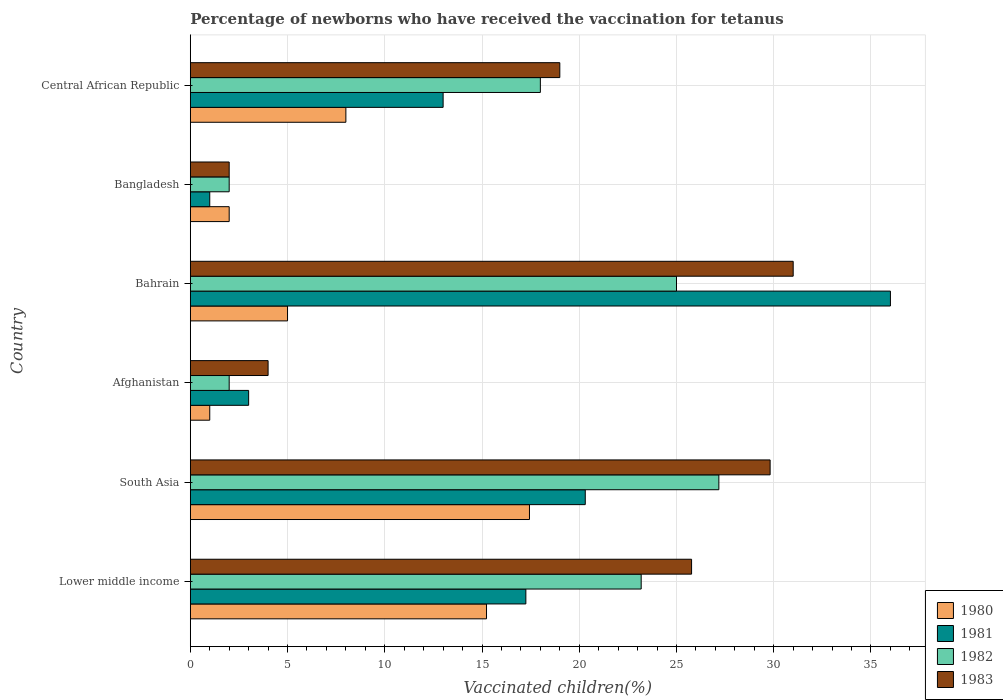How many different coloured bars are there?
Ensure brevity in your answer.  4. How many groups of bars are there?
Your response must be concise. 6. Are the number of bars per tick equal to the number of legend labels?
Make the answer very short. Yes. How many bars are there on the 2nd tick from the top?
Make the answer very short. 4. How many bars are there on the 1st tick from the bottom?
Your answer should be compact. 4. In how many cases, is the number of bars for a given country not equal to the number of legend labels?
Offer a terse response. 0. Across all countries, what is the maximum percentage of vaccinated children in 1982?
Your answer should be compact. 27.18. Across all countries, what is the minimum percentage of vaccinated children in 1980?
Your answer should be compact. 1. In which country was the percentage of vaccinated children in 1983 maximum?
Offer a very short reply. Bahrain. In which country was the percentage of vaccinated children in 1981 minimum?
Your answer should be very brief. Bangladesh. What is the total percentage of vaccinated children in 1980 in the graph?
Your answer should be compact. 48.67. What is the difference between the percentage of vaccinated children in 1980 in Bangladesh and that in South Asia?
Your answer should be very brief. -15.44. What is the difference between the percentage of vaccinated children in 1981 in South Asia and the percentage of vaccinated children in 1982 in Afghanistan?
Your response must be concise. 18.31. What is the average percentage of vaccinated children in 1980 per country?
Your response must be concise. 8.11. What is the difference between the percentage of vaccinated children in 1981 and percentage of vaccinated children in 1982 in South Asia?
Offer a terse response. -6.87. In how many countries, is the percentage of vaccinated children in 1982 greater than 15 %?
Ensure brevity in your answer.  4. What is the ratio of the percentage of vaccinated children in 1981 in Bangladesh to that in South Asia?
Your response must be concise. 0.05. Is the percentage of vaccinated children in 1982 in Bahrain less than that in Bangladesh?
Provide a succinct answer. No. Is the difference between the percentage of vaccinated children in 1981 in Central African Republic and South Asia greater than the difference between the percentage of vaccinated children in 1982 in Central African Republic and South Asia?
Offer a very short reply. Yes. What is the difference between the highest and the second highest percentage of vaccinated children in 1983?
Your answer should be compact. 1.19. What is the difference between the highest and the lowest percentage of vaccinated children in 1980?
Offer a very short reply. 16.44. Is the sum of the percentage of vaccinated children in 1982 in Bangladesh and South Asia greater than the maximum percentage of vaccinated children in 1981 across all countries?
Give a very brief answer. No. Is it the case that in every country, the sum of the percentage of vaccinated children in 1982 and percentage of vaccinated children in 1980 is greater than the sum of percentage of vaccinated children in 1981 and percentage of vaccinated children in 1983?
Your response must be concise. No. Is it the case that in every country, the sum of the percentage of vaccinated children in 1982 and percentage of vaccinated children in 1980 is greater than the percentage of vaccinated children in 1981?
Provide a short and direct response. No. How many countries are there in the graph?
Your answer should be very brief. 6. Does the graph contain any zero values?
Make the answer very short. No. How many legend labels are there?
Offer a very short reply. 4. What is the title of the graph?
Provide a succinct answer. Percentage of newborns who have received the vaccination for tetanus. Does "2003" appear as one of the legend labels in the graph?
Give a very brief answer. No. What is the label or title of the X-axis?
Offer a terse response. Vaccinated children(%). What is the Vaccinated children(%) in 1980 in Lower middle income?
Provide a short and direct response. 15.23. What is the Vaccinated children(%) of 1981 in Lower middle income?
Offer a terse response. 17.25. What is the Vaccinated children(%) in 1982 in Lower middle income?
Offer a very short reply. 23.18. What is the Vaccinated children(%) of 1983 in Lower middle income?
Keep it short and to the point. 25.78. What is the Vaccinated children(%) of 1980 in South Asia?
Your answer should be very brief. 17.44. What is the Vaccinated children(%) in 1981 in South Asia?
Your answer should be compact. 20.31. What is the Vaccinated children(%) in 1982 in South Asia?
Make the answer very short. 27.18. What is the Vaccinated children(%) of 1983 in South Asia?
Keep it short and to the point. 29.81. What is the Vaccinated children(%) of 1980 in Afghanistan?
Offer a very short reply. 1. What is the Vaccinated children(%) in 1980 in Bahrain?
Make the answer very short. 5. What is the Vaccinated children(%) of 1981 in Bahrain?
Your answer should be very brief. 36. What is the Vaccinated children(%) of 1983 in Bahrain?
Provide a short and direct response. 31. What is the Vaccinated children(%) in 1981 in Bangladesh?
Provide a short and direct response. 1. Across all countries, what is the maximum Vaccinated children(%) of 1980?
Provide a succinct answer. 17.44. Across all countries, what is the maximum Vaccinated children(%) in 1982?
Provide a succinct answer. 27.18. Across all countries, what is the minimum Vaccinated children(%) in 1980?
Keep it short and to the point. 1. What is the total Vaccinated children(%) of 1980 in the graph?
Ensure brevity in your answer.  48.67. What is the total Vaccinated children(%) in 1981 in the graph?
Give a very brief answer. 90.56. What is the total Vaccinated children(%) of 1982 in the graph?
Offer a very short reply. 97.36. What is the total Vaccinated children(%) of 1983 in the graph?
Your answer should be compact. 111.59. What is the difference between the Vaccinated children(%) in 1980 in Lower middle income and that in South Asia?
Your answer should be very brief. -2.21. What is the difference between the Vaccinated children(%) of 1981 in Lower middle income and that in South Asia?
Make the answer very short. -3.05. What is the difference between the Vaccinated children(%) of 1982 in Lower middle income and that in South Asia?
Make the answer very short. -3.99. What is the difference between the Vaccinated children(%) in 1983 in Lower middle income and that in South Asia?
Give a very brief answer. -4.04. What is the difference between the Vaccinated children(%) in 1980 in Lower middle income and that in Afghanistan?
Offer a very short reply. 14.23. What is the difference between the Vaccinated children(%) of 1981 in Lower middle income and that in Afghanistan?
Your answer should be compact. 14.25. What is the difference between the Vaccinated children(%) of 1982 in Lower middle income and that in Afghanistan?
Offer a terse response. 21.18. What is the difference between the Vaccinated children(%) of 1983 in Lower middle income and that in Afghanistan?
Keep it short and to the point. 21.78. What is the difference between the Vaccinated children(%) of 1980 in Lower middle income and that in Bahrain?
Keep it short and to the point. 10.23. What is the difference between the Vaccinated children(%) of 1981 in Lower middle income and that in Bahrain?
Make the answer very short. -18.75. What is the difference between the Vaccinated children(%) in 1982 in Lower middle income and that in Bahrain?
Make the answer very short. -1.82. What is the difference between the Vaccinated children(%) in 1983 in Lower middle income and that in Bahrain?
Provide a succinct answer. -5.22. What is the difference between the Vaccinated children(%) of 1980 in Lower middle income and that in Bangladesh?
Provide a short and direct response. 13.23. What is the difference between the Vaccinated children(%) of 1981 in Lower middle income and that in Bangladesh?
Your response must be concise. 16.25. What is the difference between the Vaccinated children(%) of 1982 in Lower middle income and that in Bangladesh?
Your answer should be compact. 21.18. What is the difference between the Vaccinated children(%) of 1983 in Lower middle income and that in Bangladesh?
Give a very brief answer. 23.78. What is the difference between the Vaccinated children(%) of 1980 in Lower middle income and that in Central African Republic?
Keep it short and to the point. 7.23. What is the difference between the Vaccinated children(%) in 1981 in Lower middle income and that in Central African Republic?
Offer a terse response. 4.25. What is the difference between the Vaccinated children(%) of 1982 in Lower middle income and that in Central African Republic?
Make the answer very short. 5.18. What is the difference between the Vaccinated children(%) of 1983 in Lower middle income and that in Central African Republic?
Your answer should be compact. 6.78. What is the difference between the Vaccinated children(%) of 1980 in South Asia and that in Afghanistan?
Ensure brevity in your answer.  16.44. What is the difference between the Vaccinated children(%) of 1981 in South Asia and that in Afghanistan?
Give a very brief answer. 17.31. What is the difference between the Vaccinated children(%) of 1982 in South Asia and that in Afghanistan?
Your answer should be very brief. 25.18. What is the difference between the Vaccinated children(%) of 1983 in South Asia and that in Afghanistan?
Your answer should be compact. 25.81. What is the difference between the Vaccinated children(%) in 1980 in South Asia and that in Bahrain?
Offer a terse response. 12.44. What is the difference between the Vaccinated children(%) in 1981 in South Asia and that in Bahrain?
Keep it short and to the point. -15.69. What is the difference between the Vaccinated children(%) in 1982 in South Asia and that in Bahrain?
Your answer should be compact. 2.18. What is the difference between the Vaccinated children(%) in 1983 in South Asia and that in Bahrain?
Make the answer very short. -1.19. What is the difference between the Vaccinated children(%) in 1980 in South Asia and that in Bangladesh?
Your answer should be compact. 15.44. What is the difference between the Vaccinated children(%) of 1981 in South Asia and that in Bangladesh?
Offer a terse response. 19.31. What is the difference between the Vaccinated children(%) in 1982 in South Asia and that in Bangladesh?
Offer a very short reply. 25.18. What is the difference between the Vaccinated children(%) in 1983 in South Asia and that in Bangladesh?
Your answer should be compact. 27.81. What is the difference between the Vaccinated children(%) in 1980 in South Asia and that in Central African Republic?
Ensure brevity in your answer.  9.44. What is the difference between the Vaccinated children(%) in 1981 in South Asia and that in Central African Republic?
Provide a succinct answer. 7.31. What is the difference between the Vaccinated children(%) of 1982 in South Asia and that in Central African Republic?
Ensure brevity in your answer.  9.18. What is the difference between the Vaccinated children(%) in 1983 in South Asia and that in Central African Republic?
Offer a very short reply. 10.81. What is the difference between the Vaccinated children(%) of 1981 in Afghanistan and that in Bahrain?
Your answer should be very brief. -33. What is the difference between the Vaccinated children(%) of 1982 in Afghanistan and that in Bahrain?
Give a very brief answer. -23. What is the difference between the Vaccinated children(%) in 1983 in Afghanistan and that in Bangladesh?
Provide a succinct answer. 2. What is the difference between the Vaccinated children(%) in 1980 in Bahrain and that in Bangladesh?
Your response must be concise. 3. What is the difference between the Vaccinated children(%) in 1981 in Bahrain and that in Bangladesh?
Your response must be concise. 35. What is the difference between the Vaccinated children(%) in 1981 in Bahrain and that in Central African Republic?
Ensure brevity in your answer.  23. What is the difference between the Vaccinated children(%) of 1983 in Bahrain and that in Central African Republic?
Make the answer very short. 12. What is the difference between the Vaccinated children(%) of 1980 in Lower middle income and the Vaccinated children(%) of 1981 in South Asia?
Offer a very short reply. -5.08. What is the difference between the Vaccinated children(%) of 1980 in Lower middle income and the Vaccinated children(%) of 1982 in South Asia?
Ensure brevity in your answer.  -11.95. What is the difference between the Vaccinated children(%) in 1980 in Lower middle income and the Vaccinated children(%) in 1983 in South Asia?
Your response must be concise. -14.58. What is the difference between the Vaccinated children(%) in 1981 in Lower middle income and the Vaccinated children(%) in 1982 in South Asia?
Your response must be concise. -9.92. What is the difference between the Vaccinated children(%) of 1981 in Lower middle income and the Vaccinated children(%) of 1983 in South Asia?
Offer a very short reply. -12.56. What is the difference between the Vaccinated children(%) of 1982 in Lower middle income and the Vaccinated children(%) of 1983 in South Asia?
Provide a short and direct response. -6.63. What is the difference between the Vaccinated children(%) in 1980 in Lower middle income and the Vaccinated children(%) in 1981 in Afghanistan?
Offer a terse response. 12.23. What is the difference between the Vaccinated children(%) in 1980 in Lower middle income and the Vaccinated children(%) in 1982 in Afghanistan?
Keep it short and to the point. 13.23. What is the difference between the Vaccinated children(%) in 1980 in Lower middle income and the Vaccinated children(%) in 1983 in Afghanistan?
Provide a succinct answer. 11.23. What is the difference between the Vaccinated children(%) in 1981 in Lower middle income and the Vaccinated children(%) in 1982 in Afghanistan?
Give a very brief answer. 15.25. What is the difference between the Vaccinated children(%) of 1981 in Lower middle income and the Vaccinated children(%) of 1983 in Afghanistan?
Keep it short and to the point. 13.25. What is the difference between the Vaccinated children(%) of 1982 in Lower middle income and the Vaccinated children(%) of 1983 in Afghanistan?
Offer a terse response. 19.18. What is the difference between the Vaccinated children(%) of 1980 in Lower middle income and the Vaccinated children(%) of 1981 in Bahrain?
Give a very brief answer. -20.77. What is the difference between the Vaccinated children(%) in 1980 in Lower middle income and the Vaccinated children(%) in 1982 in Bahrain?
Ensure brevity in your answer.  -9.77. What is the difference between the Vaccinated children(%) of 1980 in Lower middle income and the Vaccinated children(%) of 1983 in Bahrain?
Your response must be concise. -15.77. What is the difference between the Vaccinated children(%) of 1981 in Lower middle income and the Vaccinated children(%) of 1982 in Bahrain?
Give a very brief answer. -7.75. What is the difference between the Vaccinated children(%) in 1981 in Lower middle income and the Vaccinated children(%) in 1983 in Bahrain?
Your answer should be very brief. -13.75. What is the difference between the Vaccinated children(%) in 1982 in Lower middle income and the Vaccinated children(%) in 1983 in Bahrain?
Keep it short and to the point. -7.82. What is the difference between the Vaccinated children(%) of 1980 in Lower middle income and the Vaccinated children(%) of 1981 in Bangladesh?
Your response must be concise. 14.23. What is the difference between the Vaccinated children(%) of 1980 in Lower middle income and the Vaccinated children(%) of 1982 in Bangladesh?
Offer a very short reply. 13.23. What is the difference between the Vaccinated children(%) in 1980 in Lower middle income and the Vaccinated children(%) in 1983 in Bangladesh?
Offer a very short reply. 13.23. What is the difference between the Vaccinated children(%) of 1981 in Lower middle income and the Vaccinated children(%) of 1982 in Bangladesh?
Ensure brevity in your answer.  15.25. What is the difference between the Vaccinated children(%) in 1981 in Lower middle income and the Vaccinated children(%) in 1983 in Bangladesh?
Make the answer very short. 15.25. What is the difference between the Vaccinated children(%) of 1982 in Lower middle income and the Vaccinated children(%) of 1983 in Bangladesh?
Ensure brevity in your answer.  21.18. What is the difference between the Vaccinated children(%) of 1980 in Lower middle income and the Vaccinated children(%) of 1981 in Central African Republic?
Your answer should be compact. 2.23. What is the difference between the Vaccinated children(%) in 1980 in Lower middle income and the Vaccinated children(%) in 1982 in Central African Republic?
Ensure brevity in your answer.  -2.77. What is the difference between the Vaccinated children(%) in 1980 in Lower middle income and the Vaccinated children(%) in 1983 in Central African Republic?
Offer a very short reply. -3.77. What is the difference between the Vaccinated children(%) in 1981 in Lower middle income and the Vaccinated children(%) in 1982 in Central African Republic?
Give a very brief answer. -0.75. What is the difference between the Vaccinated children(%) in 1981 in Lower middle income and the Vaccinated children(%) in 1983 in Central African Republic?
Offer a very short reply. -1.75. What is the difference between the Vaccinated children(%) in 1982 in Lower middle income and the Vaccinated children(%) in 1983 in Central African Republic?
Your answer should be very brief. 4.18. What is the difference between the Vaccinated children(%) in 1980 in South Asia and the Vaccinated children(%) in 1981 in Afghanistan?
Keep it short and to the point. 14.44. What is the difference between the Vaccinated children(%) in 1980 in South Asia and the Vaccinated children(%) in 1982 in Afghanistan?
Provide a succinct answer. 15.44. What is the difference between the Vaccinated children(%) in 1980 in South Asia and the Vaccinated children(%) in 1983 in Afghanistan?
Your answer should be very brief. 13.44. What is the difference between the Vaccinated children(%) in 1981 in South Asia and the Vaccinated children(%) in 1982 in Afghanistan?
Make the answer very short. 18.31. What is the difference between the Vaccinated children(%) of 1981 in South Asia and the Vaccinated children(%) of 1983 in Afghanistan?
Offer a terse response. 16.31. What is the difference between the Vaccinated children(%) of 1982 in South Asia and the Vaccinated children(%) of 1983 in Afghanistan?
Provide a succinct answer. 23.18. What is the difference between the Vaccinated children(%) in 1980 in South Asia and the Vaccinated children(%) in 1981 in Bahrain?
Give a very brief answer. -18.56. What is the difference between the Vaccinated children(%) of 1980 in South Asia and the Vaccinated children(%) of 1982 in Bahrain?
Ensure brevity in your answer.  -7.56. What is the difference between the Vaccinated children(%) in 1980 in South Asia and the Vaccinated children(%) in 1983 in Bahrain?
Make the answer very short. -13.56. What is the difference between the Vaccinated children(%) in 1981 in South Asia and the Vaccinated children(%) in 1982 in Bahrain?
Provide a succinct answer. -4.69. What is the difference between the Vaccinated children(%) in 1981 in South Asia and the Vaccinated children(%) in 1983 in Bahrain?
Provide a succinct answer. -10.69. What is the difference between the Vaccinated children(%) in 1982 in South Asia and the Vaccinated children(%) in 1983 in Bahrain?
Provide a short and direct response. -3.82. What is the difference between the Vaccinated children(%) of 1980 in South Asia and the Vaccinated children(%) of 1981 in Bangladesh?
Provide a short and direct response. 16.44. What is the difference between the Vaccinated children(%) of 1980 in South Asia and the Vaccinated children(%) of 1982 in Bangladesh?
Provide a succinct answer. 15.44. What is the difference between the Vaccinated children(%) in 1980 in South Asia and the Vaccinated children(%) in 1983 in Bangladesh?
Keep it short and to the point. 15.44. What is the difference between the Vaccinated children(%) of 1981 in South Asia and the Vaccinated children(%) of 1982 in Bangladesh?
Offer a terse response. 18.31. What is the difference between the Vaccinated children(%) in 1981 in South Asia and the Vaccinated children(%) in 1983 in Bangladesh?
Provide a short and direct response. 18.31. What is the difference between the Vaccinated children(%) of 1982 in South Asia and the Vaccinated children(%) of 1983 in Bangladesh?
Your answer should be very brief. 25.18. What is the difference between the Vaccinated children(%) of 1980 in South Asia and the Vaccinated children(%) of 1981 in Central African Republic?
Offer a terse response. 4.44. What is the difference between the Vaccinated children(%) in 1980 in South Asia and the Vaccinated children(%) in 1982 in Central African Republic?
Ensure brevity in your answer.  -0.56. What is the difference between the Vaccinated children(%) of 1980 in South Asia and the Vaccinated children(%) of 1983 in Central African Republic?
Ensure brevity in your answer.  -1.56. What is the difference between the Vaccinated children(%) in 1981 in South Asia and the Vaccinated children(%) in 1982 in Central African Republic?
Ensure brevity in your answer.  2.31. What is the difference between the Vaccinated children(%) in 1981 in South Asia and the Vaccinated children(%) in 1983 in Central African Republic?
Provide a short and direct response. 1.31. What is the difference between the Vaccinated children(%) of 1982 in South Asia and the Vaccinated children(%) of 1983 in Central African Republic?
Offer a terse response. 8.18. What is the difference between the Vaccinated children(%) of 1980 in Afghanistan and the Vaccinated children(%) of 1981 in Bahrain?
Your response must be concise. -35. What is the difference between the Vaccinated children(%) in 1981 in Afghanistan and the Vaccinated children(%) in 1982 in Bahrain?
Keep it short and to the point. -22. What is the difference between the Vaccinated children(%) in 1981 in Afghanistan and the Vaccinated children(%) in 1983 in Bahrain?
Your answer should be very brief. -28. What is the difference between the Vaccinated children(%) in 1982 in Afghanistan and the Vaccinated children(%) in 1983 in Bahrain?
Keep it short and to the point. -29. What is the difference between the Vaccinated children(%) of 1980 in Afghanistan and the Vaccinated children(%) of 1981 in Bangladesh?
Provide a short and direct response. 0. What is the difference between the Vaccinated children(%) in 1981 in Afghanistan and the Vaccinated children(%) in 1982 in Bangladesh?
Provide a short and direct response. 1. What is the difference between the Vaccinated children(%) of 1981 in Afghanistan and the Vaccinated children(%) of 1983 in Bangladesh?
Ensure brevity in your answer.  1. What is the difference between the Vaccinated children(%) of 1980 in Afghanistan and the Vaccinated children(%) of 1982 in Central African Republic?
Ensure brevity in your answer.  -17. What is the difference between the Vaccinated children(%) of 1980 in Afghanistan and the Vaccinated children(%) of 1983 in Central African Republic?
Keep it short and to the point. -18. What is the difference between the Vaccinated children(%) of 1980 in Bahrain and the Vaccinated children(%) of 1981 in Bangladesh?
Give a very brief answer. 4. What is the difference between the Vaccinated children(%) in 1980 in Bahrain and the Vaccinated children(%) in 1982 in Bangladesh?
Make the answer very short. 3. What is the difference between the Vaccinated children(%) in 1980 in Bahrain and the Vaccinated children(%) in 1983 in Bangladesh?
Keep it short and to the point. 3. What is the difference between the Vaccinated children(%) of 1981 in Bahrain and the Vaccinated children(%) of 1982 in Bangladesh?
Offer a terse response. 34. What is the difference between the Vaccinated children(%) of 1980 in Bahrain and the Vaccinated children(%) of 1981 in Central African Republic?
Make the answer very short. -8. What is the difference between the Vaccinated children(%) of 1980 in Bahrain and the Vaccinated children(%) of 1982 in Central African Republic?
Offer a terse response. -13. What is the difference between the Vaccinated children(%) in 1980 in Bahrain and the Vaccinated children(%) in 1983 in Central African Republic?
Offer a terse response. -14. What is the difference between the Vaccinated children(%) in 1982 in Bahrain and the Vaccinated children(%) in 1983 in Central African Republic?
Your answer should be very brief. 6. What is the difference between the Vaccinated children(%) of 1980 in Bangladesh and the Vaccinated children(%) of 1981 in Central African Republic?
Your answer should be very brief. -11. What is the difference between the Vaccinated children(%) in 1980 in Bangladesh and the Vaccinated children(%) in 1982 in Central African Republic?
Your answer should be compact. -16. What is the difference between the Vaccinated children(%) in 1980 in Bangladesh and the Vaccinated children(%) in 1983 in Central African Republic?
Your answer should be very brief. -17. What is the difference between the Vaccinated children(%) of 1981 in Bangladesh and the Vaccinated children(%) of 1983 in Central African Republic?
Ensure brevity in your answer.  -18. What is the average Vaccinated children(%) in 1980 per country?
Your response must be concise. 8.11. What is the average Vaccinated children(%) in 1981 per country?
Offer a terse response. 15.09. What is the average Vaccinated children(%) of 1982 per country?
Offer a terse response. 16.23. What is the average Vaccinated children(%) of 1983 per country?
Provide a short and direct response. 18.6. What is the difference between the Vaccinated children(%) of 1980 and Vaccinated children(%) of 1981 in Lower middle income?
Provide a succinct answer. -2.02. What is the difference between the Vaccinated children(%) in 1980 and Vaccinated children(%) in 1982 in Lower middle income?
Give a very brief answer. -7.95. What is the difference between the Vaccinated children(%) in 1980 and Vaccinated children(%) in 1983 in Lower middle income?
Your response must be concise. -10.54. What is the difference between the Vaccinated children(%) of 1981 and Vaccinated children(%) of 1982 in Lower middle income?
Keep it short and to the point. -5.93. What is the difference between the Vaccinated children(%) of 1981 and Vaccinated children(%) of 1983 in Lower middle income?
Your response must be concise. -8.52. What is the difference between the Vaccinated children(%) of 1982 and Vaccinated children(%) of 1983 in Lower middle income?
Your answer should be very brief. -2.59. What is the difference between the Vaccinated children(%) of 1980 and Vaccinated children(%) of 1981 in South Asia?
Your answer should be compact. -2.87. What is the difference between the Vaccinated children(%) of 1980 and Vaccinated children(%) of 1982 in South Asia?
Your answer should be very brief. -9.74. What is the difference between the Vaccinated children(%) of 1980 and Vaccinated children(%) of 1983 in South Asia?
Offer a terse response. -12.37. What is the difference between the Vaccinated children(%) of 1981 and Vaccinated children(%) of 1982 in South Asia?
Offer a very short reply. -6.87. What is the difference between the Vaccinated children(%) in 1981 and Vaccinated children(%) in 1983 in South Asia?
Keep it short and to the point. -9.51. What is the difference between the Vaccinated children(%) of 1982 and Vaccinated children(%) of 1983 in South Asia?
Offer a terse response. -2.64. What is the difference between the Vaccinated children(%) in 1980 and Vaccinated children(%) in 1982 in Afghanistan?
Give a very brief answer. -1. What is the difference between the Vaccinated children(%) in 1980 and Vaccinated children(%) in 1981 in Bahrain?
Ensure brevity in your answer.  -31. What is the difference between the Vaccinated children(%) in 1980 and Vaccinated children(%) in 1983 in Bahrain?
Offer a very short reply. -26. What is the difference between the Vaccinated children(%) of 1980 and Vaccinated children(%) of 1981 in Bangladesh?
Ensure brevity in your answer.  1. What is the difference between the Vaccinated children(%) in 1981 and Vaccinated children(%) in 1982 in Bangladesh?
Offer a terse response. -1. What is the difference between the Vaccinated children(%) of 1981 and Vaccinated children(%) of 1983 in Bangladesh?
Ensure brevity in your answer.  -1. What is the difference between the Vaccinated children(%) of 1981 and Vaccinated children(%) of 1983 in Central African Republic?
Make the answer very short. -6. What is the difference between the Vaccinated children(%) of 1982 and Vaccinated children(%) of 1983 in Central African Republic?
Offer a terse response. -1. What is the ratio of the Vaccinated children(%) of 1980 in Lower middle income to that in South Asia?
Provide a short and direct response. 0.87. What is the ratio of the Vaccinated children(%) in 1981 in Lower middle income to that in South Asia?
Offer a terse response. 0.85. What is the ratio of the Vaccinated children(%) in 1982 in Lower middle income to that in South Asia?
Provide a succinct answer. 0.85. What is the ratio of the Vaccinated children(%) of 1983 in Lower middle income to that in South Asia?
Your answer should be very brief. 0.86. What is the ratio of the Vaccinated children(%) of 1980 in Lower middle income to that in Afghanistan?
Your answer should be very brief. 15.23. What is the ratio of the Vaccinated children(%) of 1981 in Lower middle income to that in Afghanistan?
Offer a terse response. 5.75. What is the ratio of the Vaccinated children(%) in 1982 in Lower middle income to that in Afghanistan?
Offer a very short reply. 11.59. What is the ratio of the Vaccinated children(%) in 1983 in Lower middle income to that in Afghanistan?
Give a very brief answer. 6.44. What is the ratio of the Vaccinated children(%) in 1980 in Lower middle income to that in Bahrain?
Offer a terse response. 3.05. What is the ratio of the Vaccinated children(%) of 1981 in Lower middle income to that in Bahrain?
Offer a very short reply. 0.48. What is the ratio of the Vaccinated children(%) in 1982 in Lower middle income to that in Bahrain?
Provide a short and direct response. 0.93. What is the ratio of the Vaccinated children(%) in 1983 in Lower middle income to that in Bahrain?
Your response must be concise. 0.83. What is the ratio of the Vaccinated children(%) in 1980 in Lower middle income to that in Bangladesh?
Give a very brief answer. 7.62. What is the ratio of the Vaccinated children(%) of 1981 in Lower middle income to that in Bangladesh?
Make the answer very short. 17.25. What is the ratio of the Vaccinated children(%) in 1982 in Lower middle income to that in Bangladesh?
Your answer should be compact. 11.59. What is the ratio of the Vaccinated children(%) in 1983 in Lower middle income to that in Bangladesh?
Provide a succinct answer. 12.89. What is the ratio of the Vaccinated children(%) of 1980 in Lower middle income to that in Central African Republic?
Offer a very short reply. 1.9. What is the ratio of the Vaccinated children(%) of 1981 in Lower middle income to that in Central African Republic?
Provide a succinct answer. 1.33. What is the ratio of the Vaccinated children(%) of 1982 in Lower middle income to that in Central African Republic?
Your response must be concise. 1.29. What is the ratio of the Vaccinated children(%) in 1983 in Lower middle income to that in Central African Republic?
Offer a terse response. 1.36. What is the ratio of the Vaccinated children(%) of 1980 in South Asia to that in Afghanistan?
Ensure brevity in your answer.  17.44. What is the ratio of the Vaccinated children(%) in 1981 in South Asia to that in Afghanistan?
Offer a very short reply. 6.77. What is the ratio of the Vaccinated children(%) of 1982 in South Asia to that in Afghanistan?
Your response must be concise. 13.59. What is the ratio of the Vaccinated children(%) in 1983 in South Asia to that in Afghanistan?
Ensure brevity in your answer.  7.45. What is the ratio of the Vaccinated children(%) of 1980 in South Asia to that in Bahrain?
Ensure brevity in your answer.  3.49. What is the ratio of the Vaccinated children(%) of 1981 in South Asia to that in Bahrain?
Provide a succinct answer. 0.56. What is the ratio of the Vaccinated children(%) of 1982 in South Asia to that in Bahrain?
Your answer should be very brief. 1.09. What is the ratio of the Vaccinated children(%) of 1983 in South Asia to that in Bahrain?
Provide a succinct answer. 0.96. What is the ratio of the Vaccinated children(%) of 1980 in South Asia to that in Bangladesh?
Your answer should be compact. 8.72. What is the ratio of the Vaccinated children(%) in 1981 in South Asia to that in Bangladesh?
Your answer should be compact. 20.31. What is the ratio of the Vaccinated children(%) of 1982 in South Asia to that in Bangladesh?
Your response must be concise. 13.59. What is the ratio of the Vaccinated children(%) of 1983 in South Asia to that in Bangladesh?
Provide a succinct answer. 14.91. What is the ratio of the Vaccinated children(%) of 1980 in South Asia to that in Central African Republic?
Give a very brief answer. 2.18. What is the ratio of the Vaccinated children(%) in 1981 in South Asia to that in Central African Republic?
Ensure brevity in your answer.  1.56. What is the ratio of the Vaccinated children(%) of 1982 in South Asia to that in Central African Republic?
Your answer should be compact. 1.51. What is the ratio of the Vaccinated children(%) of 1983 in South Asia to that in Central African Republic?
Provide a succinct answer. 1.57. What is the ratio of the Vaccinated children(%) in 1980 in Afghanistan to that in Bahrain?
Make the answer very short. 0.2. What is the ratio of the Vaccinated children(%) of 1981 in Afghanistan to that in Bahrain?
Provide a succinct answer. 0.08. What is the ratio of the Vaccinated children(%) in 1982 in Afghanistan to that in Bahrain?
Your answer should be compact. 0.08. What is the ratio of the Vaccinated children(%) in 1983 in Afghanistan to that in Bahrain?
Provide a short and direct response. 0.13. What is the ratio of the Vaccinated children(%) of 1980 in Afghanistan to that in Bangladesh?
Make the answer very short. 0.5. What is the ratio of the Vaccinated children(%) of 1981 in Afghanistan to that in Bangladesh?
Offer a terse response. 3. What is the ratio of the Vaccinated children(%) of 1983 in Afghanistan to that in Bangladesh?
Offer a terse response. 2. What is the ratio of the Vaccinated children(%) in 1980 in Afghanistan to that in Central African Republic?
Offer a very short reply. 0.12. What is the ratio of the Vaccinated children(%) of 1981 in Afghanistan to that in Central African Republic?
Ensure brevity in your answer.  0.23. What is the ratio of the Vaccinated children(%) of 1983 in Afghanistan to that in Central African Republic?
Keep it short and to the point. 0.21. What is the ratio of the Vaccinated children(%) in 1980 in Bahrain to that in Bangladesh?
Offer a terse response. 2.5. What is the ratio of the Vaccinated children(%) in 1982 in Bahrain to that in Bangladesh?
Provide a succinct answer. 12.5. What is the ratio of the Vaccinated children(%) of 1980 in Bahrain to that in Central African Republic?
Your answer should be compact. 0.62. What is the ratio of the Vaccinated children(%) in 1981 in Bahrain to that in Central African Republic?
Ensure brevity in your answer.  2.77. What is the ratio of the Vaccinated children(%) of 1982 in Bahrain to that in Central African Republic?
Keep it short and to the point. 1.39. What is the ratio of the Vaccinated children(%) in 1983 in Bahrain to that in Central African Republic?
Provide a short and direct response. 1.63. What is the ratio of the Vaccinated children(%) in 1981 in Bangladesh to that in Central African Republic?
Provide a short and direct response. 0.08. What is the ratio of the Vaccinated children(%) of 1983 in Bangladesh to that in Central African Republic?
Provide a short and direct response. 0.11. What is the difference between the highest and the second highest Vaccinated children(%) of 1980?
Keep it short and to the point. 2.21. What is the difference between the highest and the second highest Vaccinated children(%) of 1981?
Make the answer very short. 15.69. What is the difference between the highest and the second highest Vaccinated children(%) of 1982?
Give a very brief answer. 2.18. What is the difference between the highest and the second highest Vaccinated children(%) in 1983?
Provide a short and direct response. 1.19. What is the difference between the highest and the lowest Vaccinated children(%) of 1980?
Provide a short and direct response. 16.44. What is the difference between the highest and the lowest Vaccinated children(%) in 1981?
Your answer should be very brief. 35. What is the difference between the highest and the lowest Vaccinated children(%) in 1982?
Provide a short and direct response. 25.18. What is the difference between the highest and the lowest Vaccinated children(%) of 1983?
Make the answer very short. 29. 